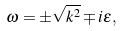<formula> <loc_0><loc_0><loc_500><loc_500>\omega = \pm \sqrt { { k } ^ { 2 } } \mp i \epsilon ,</formula> 